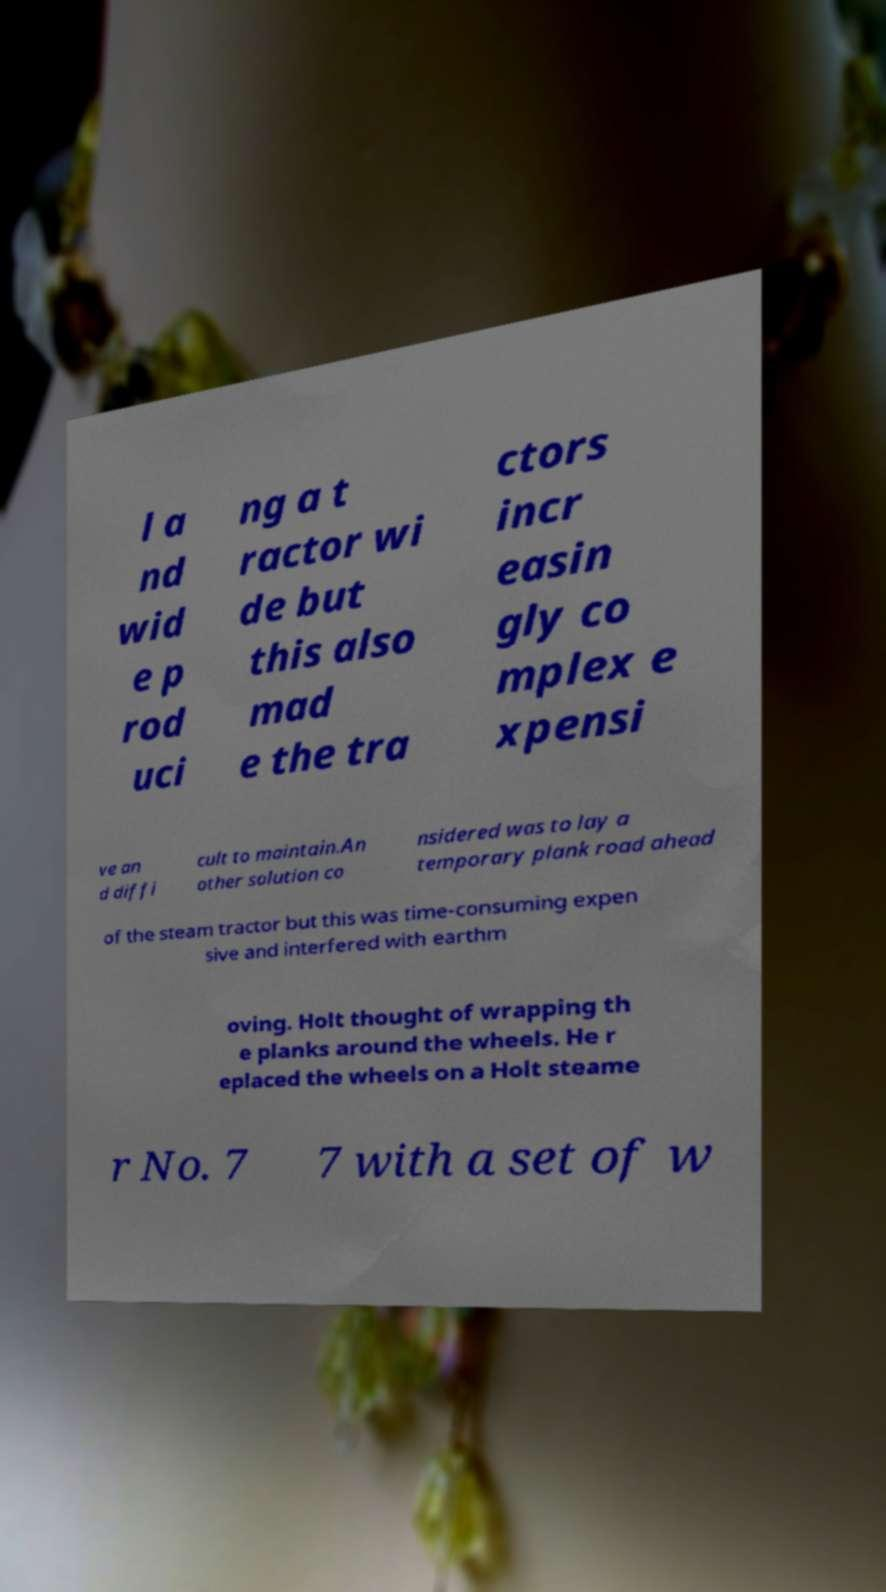Can you read and provide the text displayed in the image?This photo seems to have some interesting text. Can you extract and type it out for me? l a nd wid e p rod uci ng a t ractor wi de but this also mad e the tra ctors incr easin gly co mplex e xpensi ve an d diffi cult to maintain.An other solution co nsidered was to lay a temporary plank road ahead of the steam tractor but this was time-consuming expen sive and interfered with earthm oving. Holt thought of wrapping th e planks around the wheels. He r eplaced the wheels on a Holt steame r No. 7 7 with a set of w 